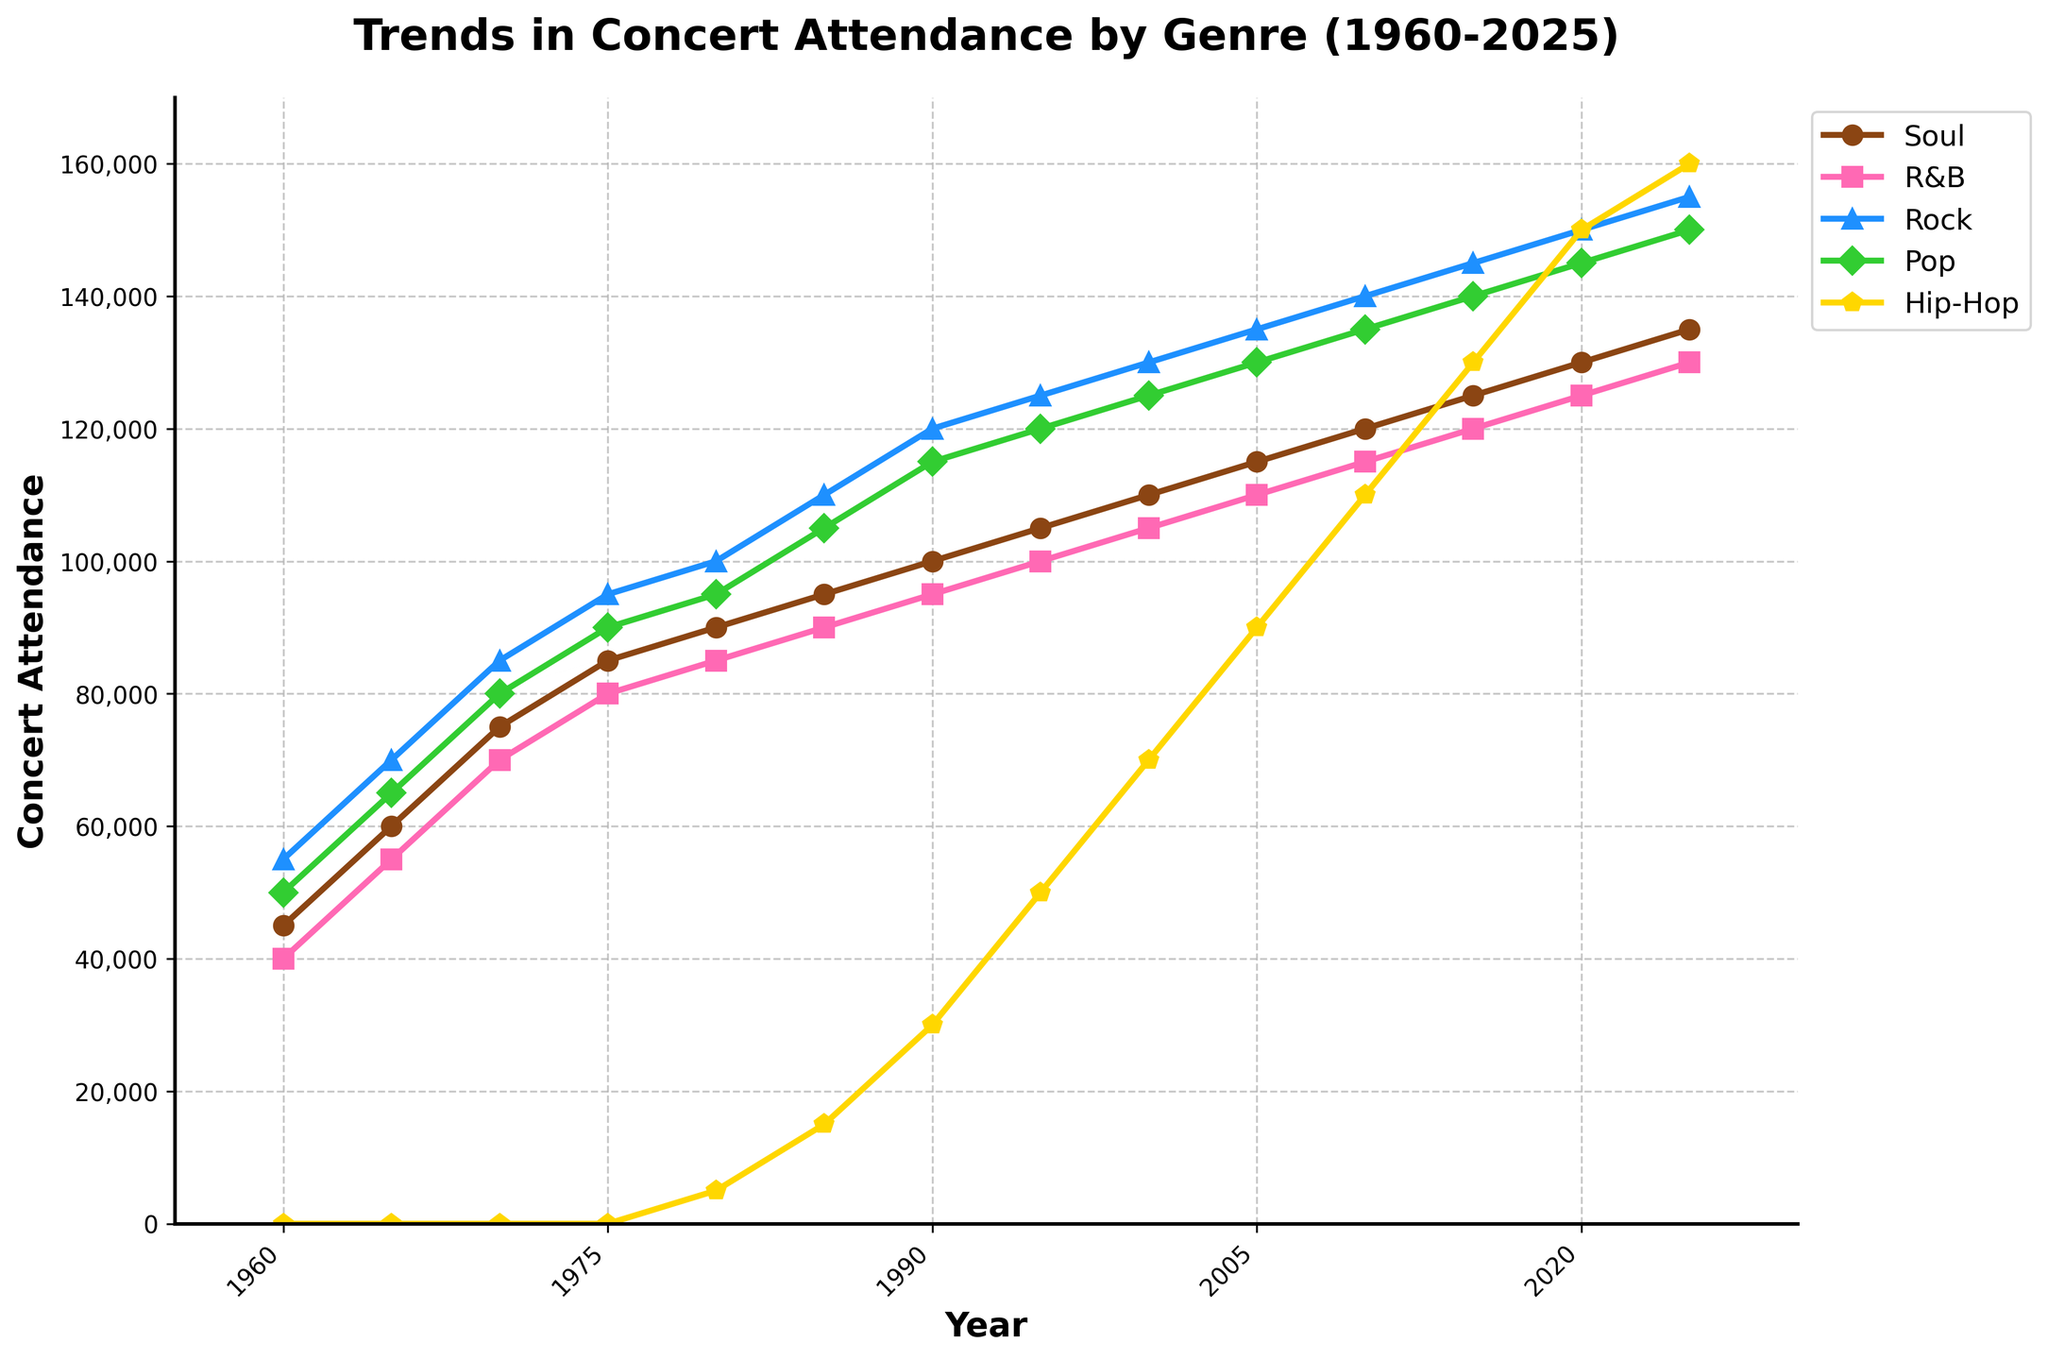What genre had the highest concert attendance in 1980? The line chart shows different attendance levels for genres in 1980. Comparing the heights of the lines for 1980, Rock has the highest concert attendance.
Answer: Rock How did the attendance for Hip-Hop concerts change from 1980 to 2000? Starting at 5000 in 1980, Hip-Hop concert attendance increased to 70000 in 2000. This shows a positive trend.
Answer: It increased Which genre had the smallest change in concert attendance from 1960 to 2025? By calculating the difference in attendance between 2025 and 1960 for all genres, R&B has the smallest change (130000 - 40000 = 90000).
Answer: R&B In which year did Soul music concerts first surpass an attendance of 100,000? Observing the Soul attendance trend, it first surpassed 100,000 between 1985 (95000) and 1990 (100000).
Answer: 1990 Compare the concert attendances for Pop and Rock in 1995. Which genre was more popular and by how much? Rock had 125000 attendees and Pop had 120000 attendees in 1995. Hence, Rock was more popular by 5000 attendees.
Answer: Rock, by 5000 Which two genres had the closest attendance figures in 2025? In 2025, Soul had 135000 and R&B had 130000 attendees, whereas the other differences were larger. Thus, closest attendance figures were between Soul and R&B.
Answer: Soul and R&B What's the average increase in concert attendance for Hip-Hop at every decade mark (1980, 1990, 2000, 2010, 2020)? The Hip-Hop attendance figures for the decades are: 5000 in 1980, 30000 in 1990, 70000 in 2000, 110000 in 2010, 150000 in 2020. Average increase: (25000 + 40000 + 40000 + 40000) / 4 = 37250
Answer: 37250 What was the overall trend in concert attendance across all genres from 1960 to 2025? Comparing the overall climb for each genre from 1960 to 2025, all genres depict an upward trend, showing increased attendance over time.
Answer: Upward trend Which year shows the biggest increase in Rock concert attendance compared to the previous year? Checking increments year by year: 1975 to 1980 had a rise from 95000 to 100000, hence a 5000 increase, the biggest individual yearly increase for Rock.
Answer: 1975 to 1980 